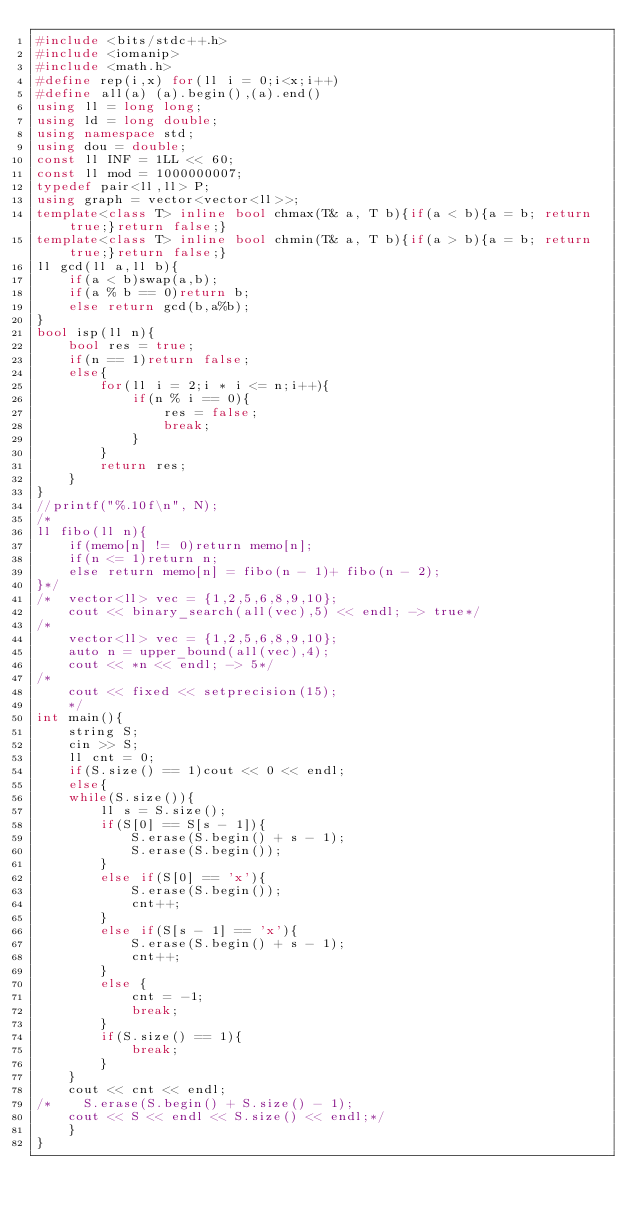Convert code to text. <code><loc_0><loc_0><loc_500><loc_500><_C++_>#include <bits/stdc++.h>
#include <iomanip>
#include <math.h>
#define rep(i,x) for(ll i = 0;i<x;i++)
#define all(a) (a).begin(),(a).end()
using ll = long long;
using ld = long double;
using namespace std;
using dou = double;
const ll INF = 1LL << 60;
const ll mod = 1000000007;
typedef pair<ll,ll> P;
using graph = vector<vector<ll>>;
template<class T> inline bool chmax(T& a, T b){if(a < b){a = b; return true;}return false;}
template<class T> inline bool chmin(T& a, T b){if(a > b){a = b; return true;}return false;}
ll gcd(ll a,ll b){
    if(a < b)swap(a,b);
    if(a % b == 0)return b;
    else return gcd(b,a%b);
}
bool isp(ll n){
    bool res = true;
    if(n == 1)return false;
    else{
        for(ll i = 2;i * i <= n;i++){
            if(n % i == 0){
                res = false;
                break;
            }
        }
        return res;
    }
}
//printf("%.10f\n", N);
/*
ll fibo(ll n){
    if(memo[n] != 0)return memo[n];
    if(n <= 1)return n;
    else return memo[n] = fibo(n - 1)+ fibo(n - 2);
}*/
/*  vector<ll> vec = {1,2,5,6,8,9,10};
    cout << binary_search(all(vec),5) << endl; -> true*/
/*
    vector<ll> vec = {1,2,5,6,8,9,10};
    auto n = upper_bound(all(vec),4);
    cout << *n << endl; -> 5*/
/*
    cout << fixed << setprecision(15);
    */
int main(){
    string S;
    cin >> S;
    ll cnt = 0;
    if(S.size() == 1)cout << 0 << endl;
    else{
    while(S.size()){
        ll s = S.size();
        if(S[0] == S[s - 1]){
            S.erase(S.begin() + s - 1);
            S.erase(S.begin());
        }
        else if(S[0] == 'x'){
            S.erase(S.begin());
            cnt++;
        }
        else if(S[s - 1] == 'x'){
            S.erase(S.begin() + s - 1);
            cnt++;
        }
        else {
            cnt = -1;
            break;
        }
        if(S.size() == 1){
            break;
        }
    }
    cout << cnt << endl;
/*    S.erase(S.begin() + S.size() - 1);
    cout << S << endl << S.size() << endl;*/
    }
}</code> 